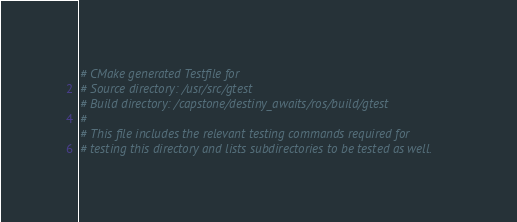Convert code to text. <code><loc_0><loc_0><loc_500><loc_500><_CMake_># CMake generated Testfile for 
# Source directory: /usr/src/gtest
# Build directory: /capstone/destiny_awaits/ros/build/gtest
# 
# This file includes the relevant testing commands required for 
# testing this directory and lists subdirectories to be tested as well.
</code> 